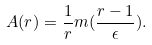<formula> <loc_0><loc_0><loc_500><loc_500>A ( r ) = \frac { 1 } { r } m ( \frac { r - 1 } { \epsilon } ) .</formula> 